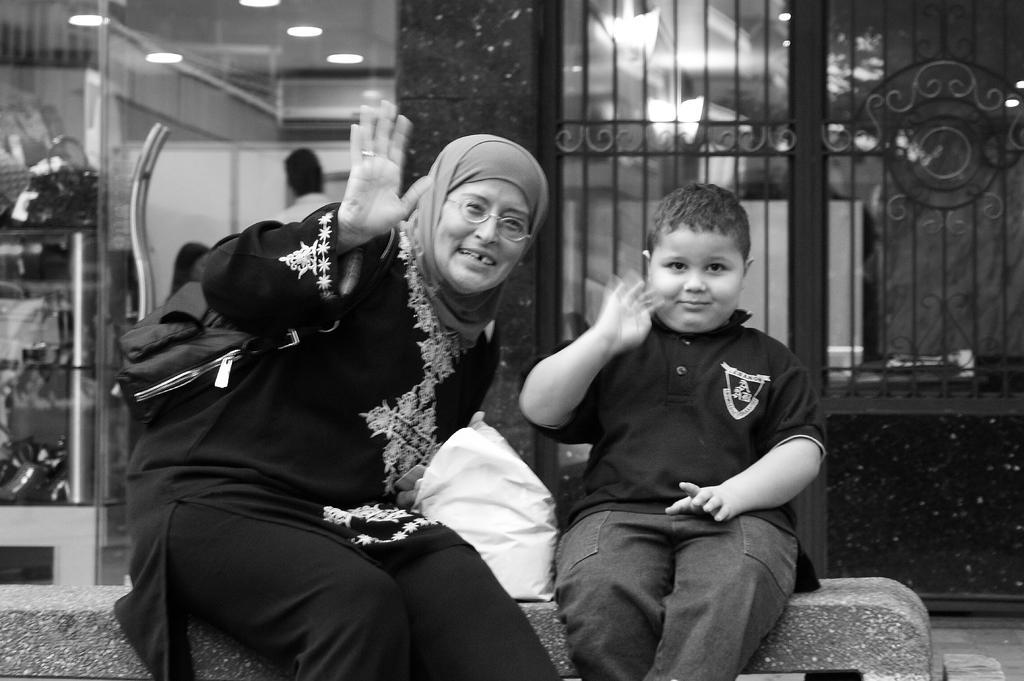How would you summarize this image in a sentence or two? In the foreground of this picture, we see a boy in black T shirt and a woman in black dress waving their hands and they are sitting on a bench. In the background, we see railing and a pillar. On left, we see a bag, a person and lights to the ceiling. 